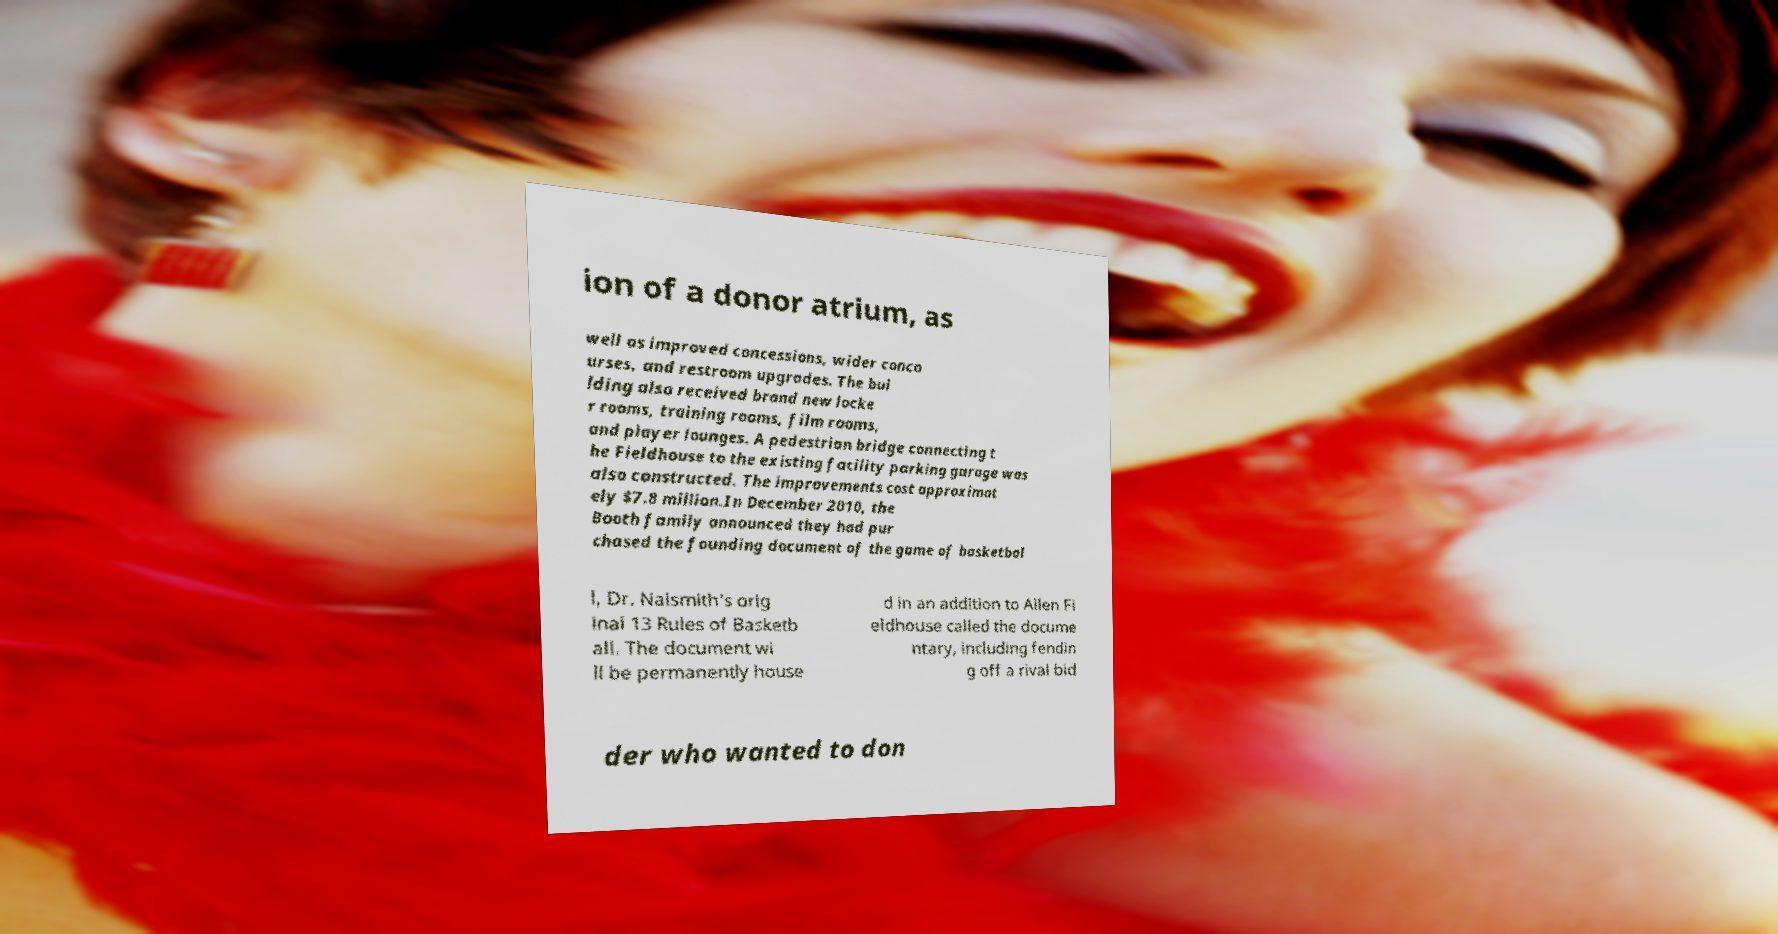Could you assist in decoding the text presented in this image and type it out clearly? ion of a donor atrium, as well as improved concessions, wider conco urses, and restroom upgrades. The bui lding also received brand new locke r rooms, training rooms, film rooms, and player lounges. A pedestrian bridge connecting t he Fieldhouse to the existing facility parking garage was also constructed. The improvements cost approximat ely $7.8 million.In December 2010, the Booth family announced they had pur chased the founding document of the game of basketbal l, Dr. Naismith's orig inal 13 Rules of Basketb all. The document wi ll be permanently house d in an addition to Allen Fi eldhouse called the docume ntary, including fendin g off a rival bid der who wanted to don 